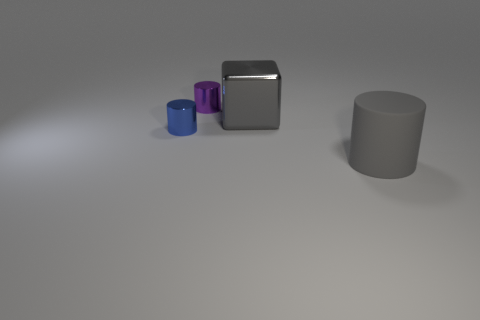Add 1 tiny metal cylinders. How many objects exist? 5 Subtract all cubes. How many objects are left? 3 Subtract all big red matte cylinders. Subtract all small blue cylinders. How many objects are left? 3 Add 2 tiny objects. How many tiny objects are left? 4 Add 3 blue rubber spheres. How many blue rubber spheres exist? 3 Subtract 0 gray balls. How many objects are left? 4 